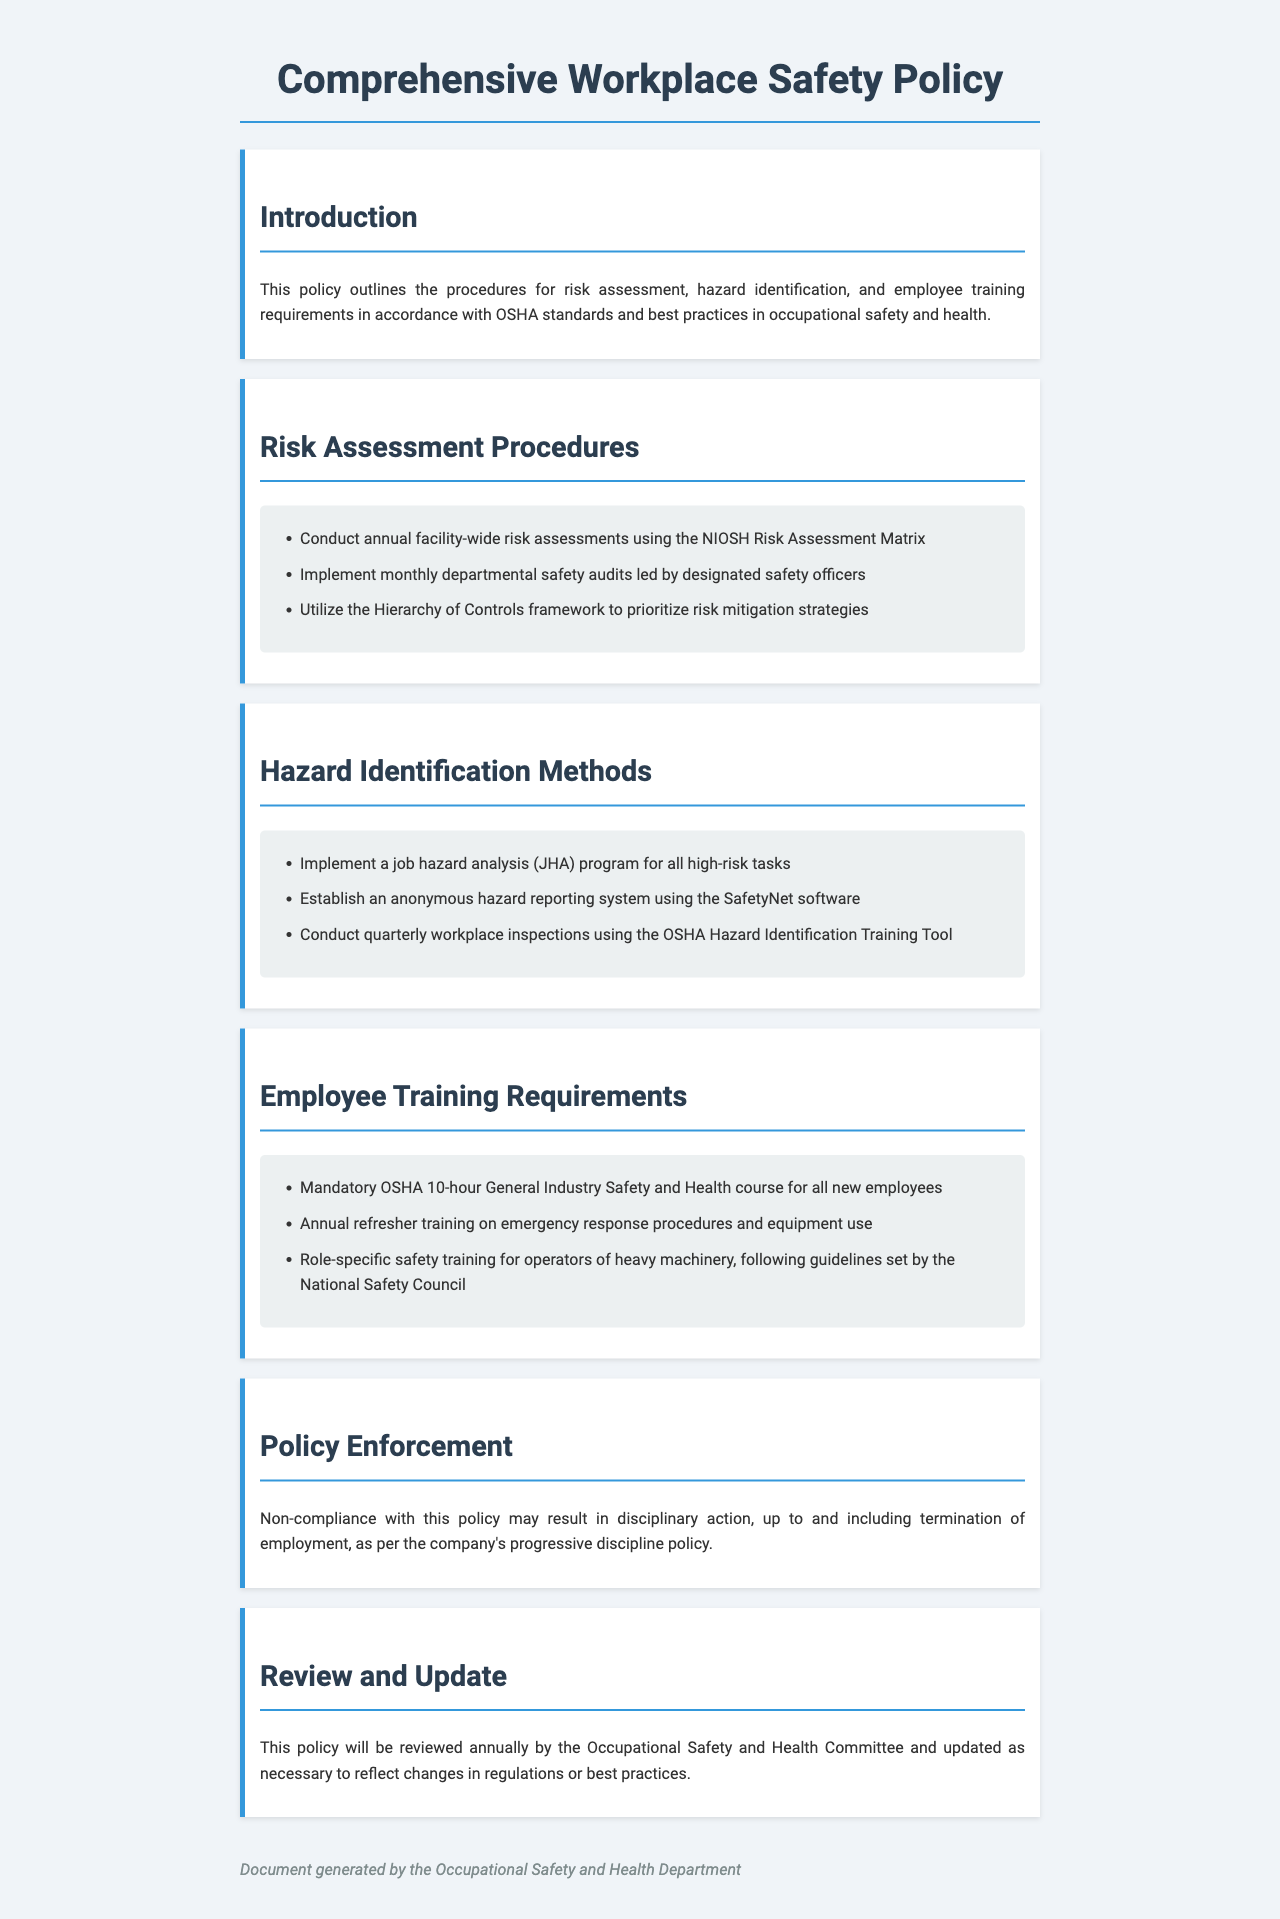What is the title of the document? The title is stated at the top of the document, which is the "Comprehensive Workplace Safety Policy."
Answer: Comprehensive Workplace Safety Policy How often should facility-wide risk assessments be conducted? The document specifies the frequency of risk assessments in the section about risk assessment procedures.
Answer: Annual What framework is used to prioritize risk mitigation strategies? The relevant section mentioned a specific framework for this purpose, which is highlighted in risk assessment procedures.
Answer: Hierarchy of Controls What type of training is mandatory for all new employees? This requirement for training is detailed in the employee training requirements section.
Answer: OSHA 10-hour General Industry Safety and Health course What software is used for the anonymous hazard reporting system? The document names the software used in the hazard identification methods section.
Answer: SafetyNet What may result from non-compliance with the policy? The consequences of non-compliance are outlined in the enforcement section of the document.
Answer: Disciplinary action How often will the policy be reviewed? The review frequency of the policy is stated in the review and update section.
Answer: Annually Which organization sets the guidelines for heavy machinery operator training? This information is provided in the employee training requirements section regarding role-specific training.
Answer: National Safety Council 